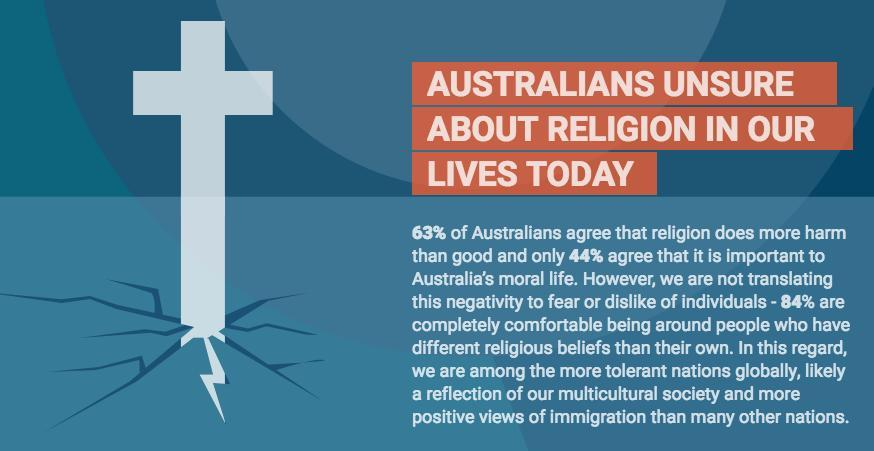What percentage of Australians do not believe that religion is important?
Answer the question with a short phrase. 56 What is the color of the cross shown in the info graphic- yellow, white, red, orange? white What percentage of Australians are not comfortable with people following different religious beliefs? 16% What percentage of Australians does not agree that religion creates more problem than relief? 37% 